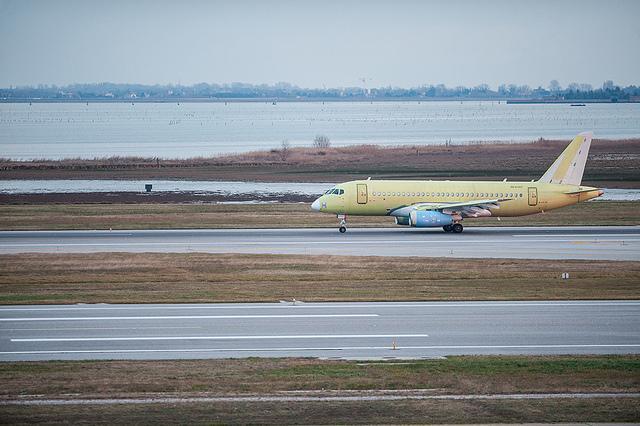How many engines are visible?
Give a very brief answer. 2. How many planes are there?
Give a very brief answer. 1. 